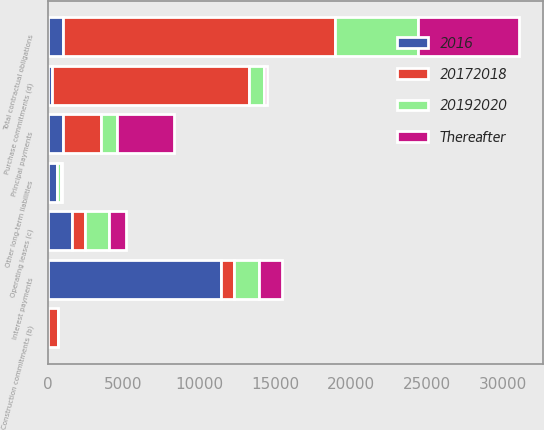Convert chart to OTSL. <chart><loc_0><loc_0><loc_500><loc_500><stacked_bar_chart><ecel><fcel>Principal payments<fcel>Interest payments<fcel>Construction commitments (b)<fcel>Operating leases (c)<fcel>Purchase commitments (d)<fcel>Other long-term liabilities<fcel>Total contractual obligations<nl><fcel>20172018<fcel>2500<fcel>855<fcel>681<fcel>863<fcel>13018<fcel>0<fcel>17917<nl><fcel>20192020<fcel>1050<fcel>1641<fcel>0<fcel>1538<fcel>989<fcel>237<fcel>5455<nl><fcel>Thereafter<fcel>3750<fcel>1552<fcel>0<fcel>1135<fcel>164<fcel>75<fcel>6676<nl><fcel>2016<fcel>1019.5<fcel>11412<fcel>0<fcel>1617<fcel>261<fcel>639<fcel>1019.5<nl></chart> 